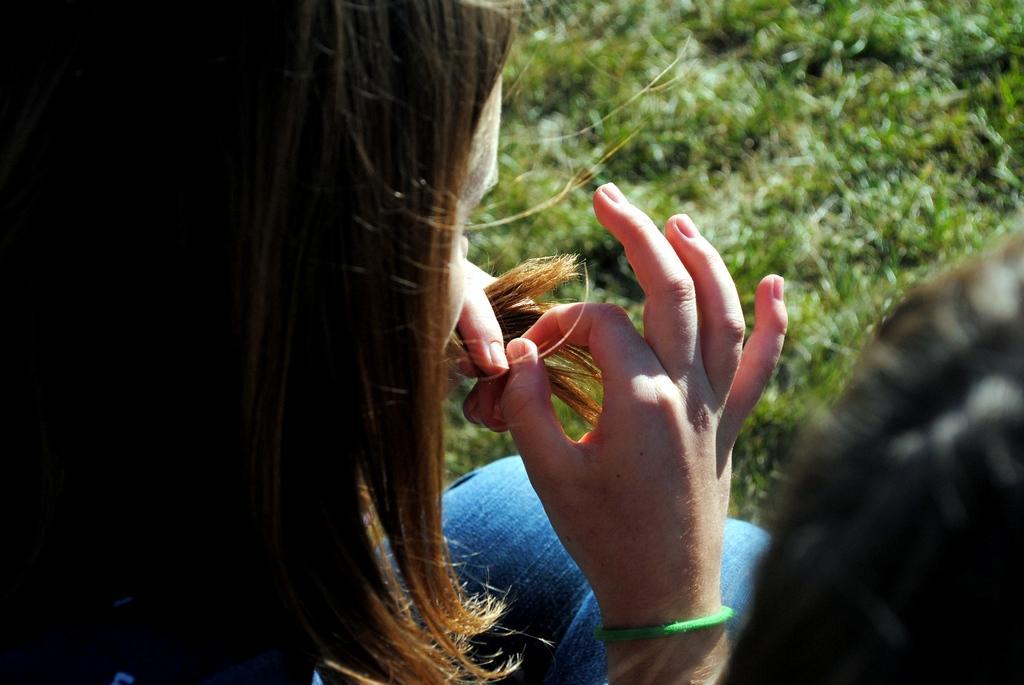In one or two sentences, can you explain what this image depicts? In this image there is a woman who is holding her hair with her hands. In front of her there is grass. On the right side bottom there is another person. 